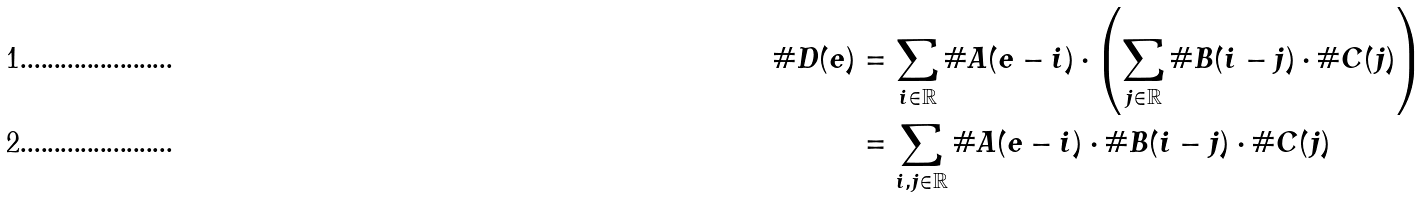<formula> <loc_0><loc_0><loc_500><loc_500>\# D ( e ) & = \sum _ { i \in \mathbb { R } } \# A ( e - i ) \cdot \left ( \sum _ { j \in \mathbb { R } } \# B ( i - j ) \cdot \# C ( j ) \right ) \\ & = \sum _ { i , j \in \mathbb { R } } \# A ( e - i ) \cdot \# B ( i - j ) \cdot \# C ( j )</formula> 